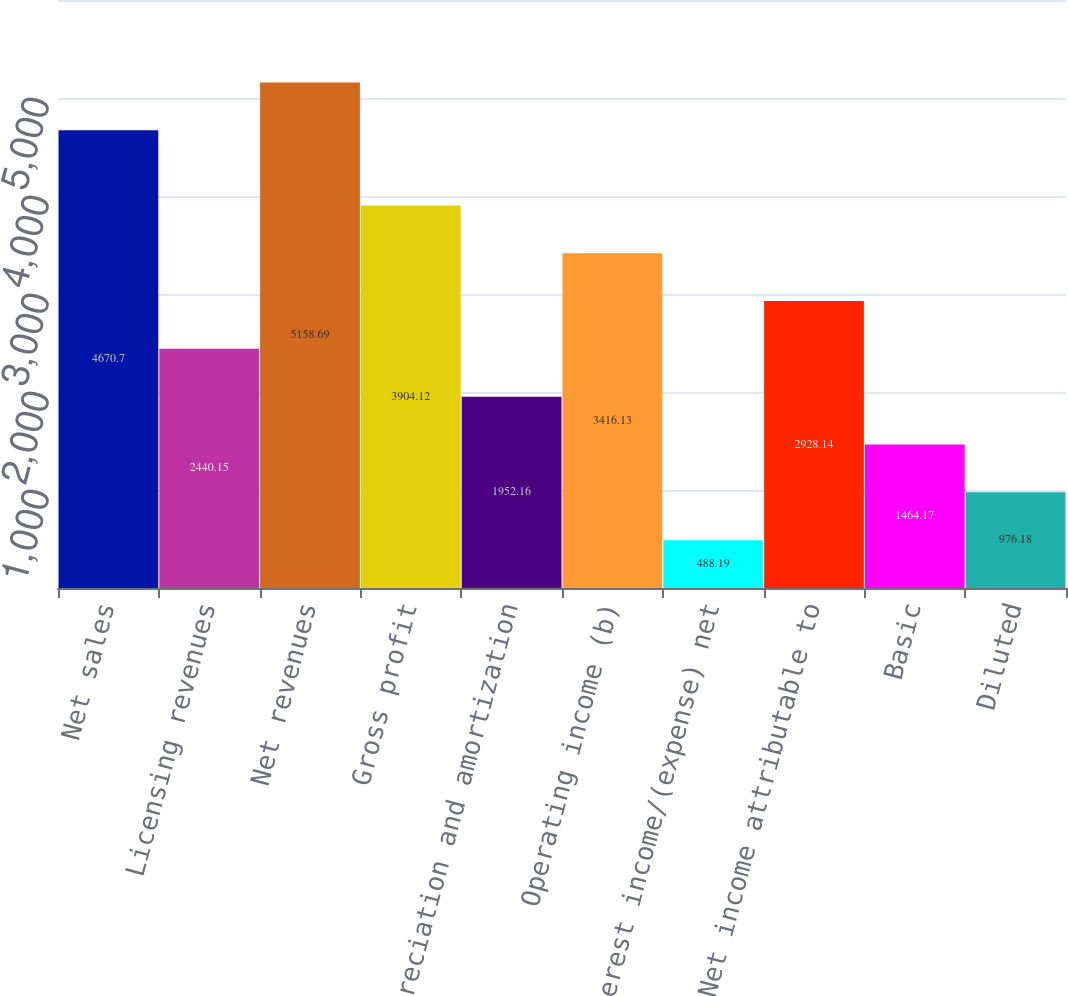<chart> <loc_0><loc_0><loc_500><loc_500><bar_chart><fcel>Net sales<fcel>Licensing revenues<fcel>Net revenues<fcel>Gross profit<fcel>Depreciation and amortization<fcel>Operating income (b)<fcel>Interest income/(expense) net<fcel>Net income attributable to<fcel>Basic<fcel>Diluted<nl><fcel>4670.7<fcel>2440.15<fcel>5158.69<fcel>3904.12<fcel>1952.16<fcel>3416.13<fcel>488.19<fcel>2928.14<fcel>1464.17<fcel>976.18<nl></chart> 